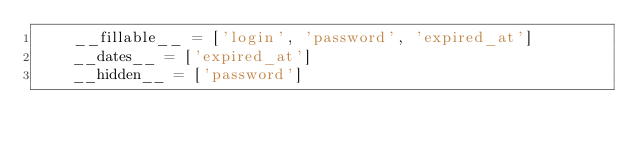<code> <loc_0><loc_0><loc_500><loc_500><_Python_>    __fillable__ = ['login', 'password', 'expired_at']
    __dates__ = ['expired_at']
    __hidden__ = ['password']

</code> 